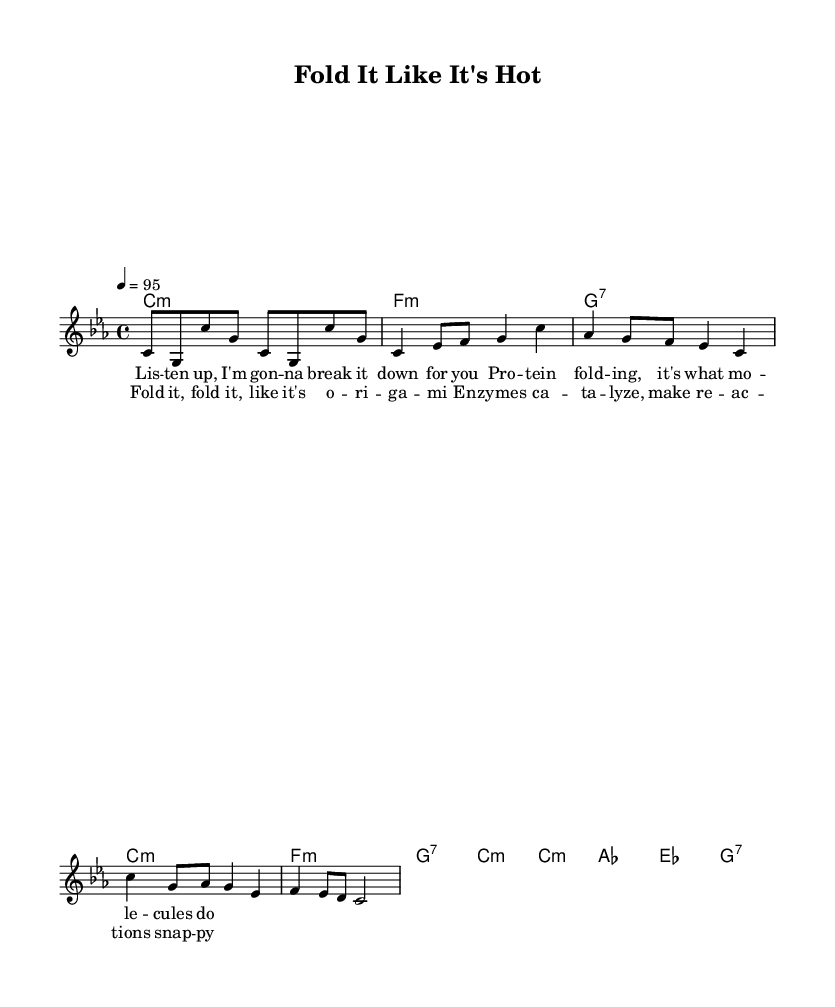What is the key signature of this music? The key signature is C minor, which has three flats (B flat, E flat, and A flat). This can be identified at the beginning of the sheet music in the key signature section.
Answer: C minor What is the time signature of this music? The time signature is 4/4, which indicates there are four beats in each measure, and the quarter note gets one beat. This is indicated at the beginning of the score.
Answer: 4/4 What is the tempo marking of this music? The tempo marking is 95 beats per minute, and it is stated in the tempo section near the beginning, indicating how fast the piece should be played.
Answer: 95 How many measures are there in the verse? There are 4 measures in the verse, which can be counted by examining the melody and observing where the bar lines divide the musical phrases.
Answer: 4 What is the main lyrical theme of the chorus? The main lyrical theme of the chorus focuses on the concepts of folding proteins and the role of enzymes in reactions. The words "Fold it, fold it..." and "enzymes catalyze" highlight this theme.
Answer: Protein folding and enzyme catalysis What chord is played in the chorus? The chord sequence in the chorus includes C minor, A flat, E flat, and G7. This can be noted in the harmonies section that accompanies the melody during the chorus.
Answer: C minor, A flat, E flat, G7 What lyrical device is used prominently in this rap? The rap prominently uses rhyme, as many of the lines end with words that phonetically complement each other, enhancing the lyrical flow and musicality. This is evident throughout the lyrics presented.
Answer: Rhyme 